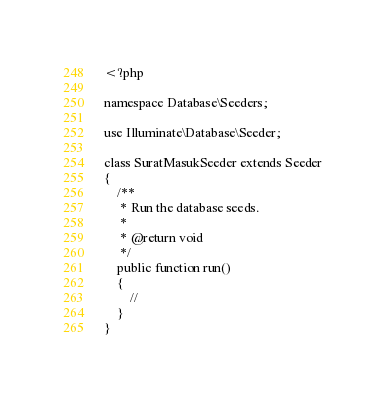<code> <loc_0><loc_0><loc_500><loc_500><_PHP_><?php

namespace Database\Seeders;

use Illuminate\Database\Seeder;

class SuratMasukSeeder extends Seeder
{
    /**
     * Run the database seeds.
     *
     * @return void
     */
    public function run()
    {
        //
    }
}
</code> 